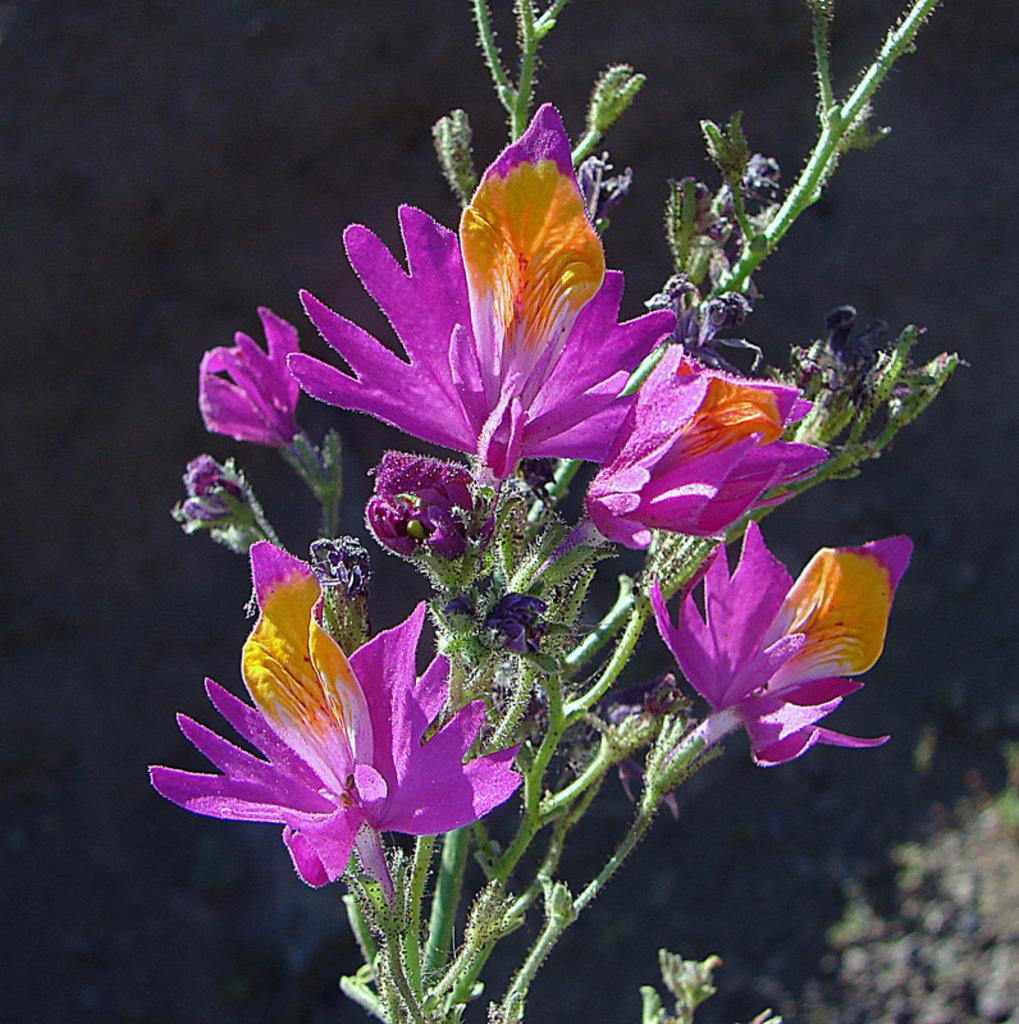What is located in the front of the image? There are flowers in the front of the image. Can you describe the background of the image? The background of the image is blurry. What happens to the flowers when they encounter a smashing force in the image? There is no smashing force present in the image, and therefore no such interaction can be observed. 